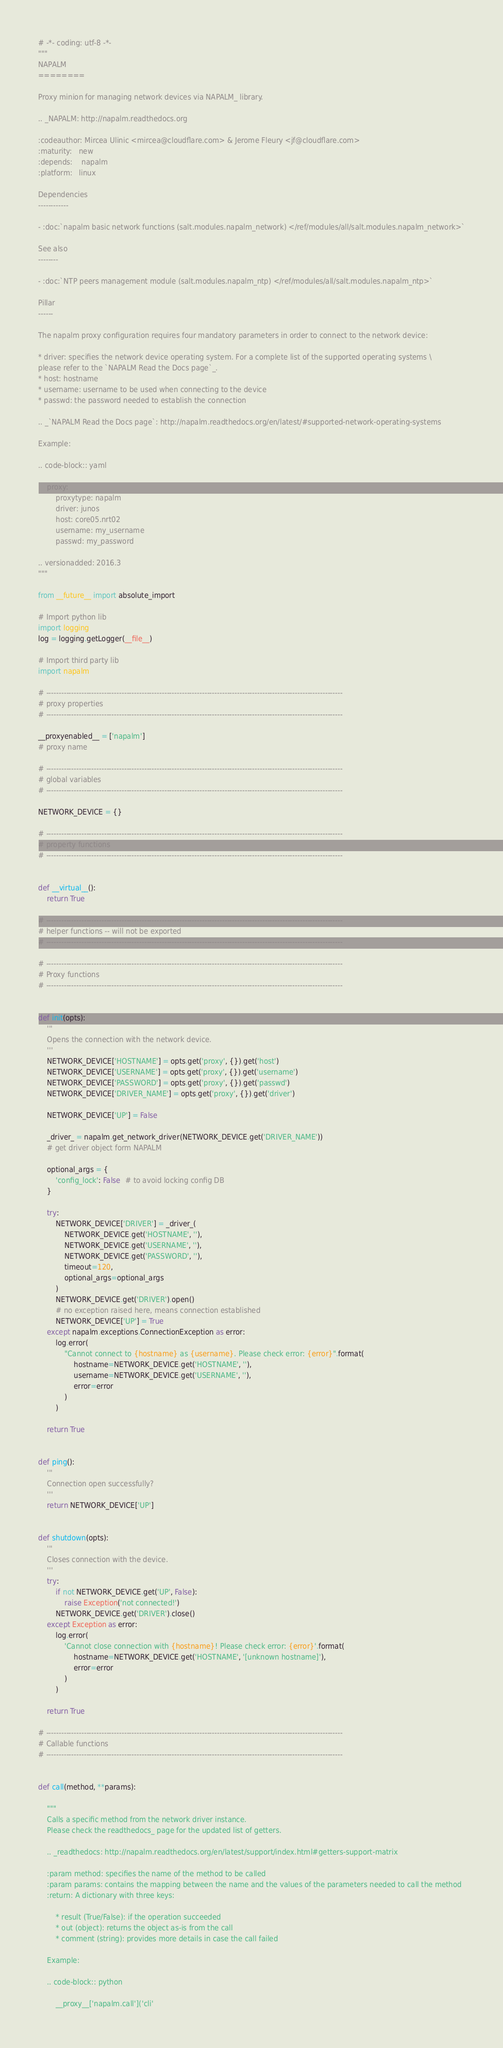<code> <loc_0><loc_0><loc_500><loc_500><_Python_># -*- coding: utf-8 -*-
"""
NAPALM
========

Proxy minion for managing network devices via NAPALM_ library.

.. _NAPALM: http://napalm.readthedocs.org

:codeauthor: Mircea Ulinic <mircea@cloudflare.com> & Jerome Fleury <jf@cloudflare.com>
:maturity:   new
:depends:    napalm
:platform:   linux

Dependencies
------------

- :doc:`napalm basic network functions (salt.modules.napalm_network) </ref/modules/all/salt.modules.napalm_network>`

See also
--------

- :doc:`NTP peers management module (salt.modules.napalm_ntp) </ref/modules/all/salt.modules.napalm_ntp>`

Pillar
------

The napalm proxy configuration requires four mandatory parameters in order to connect to the network device:

* driver: specifies the network device operating system. For a complete list of the supported operating systems \
please refer to the `NAPALM Read the Docs page`_.
* host: hostname
* username: username to be used when connecting to the device
* passwd: the password needed to establish the connection

.. _`NAPALM Read the Docs page`: http://napalm.readthedocs.org/en/latest/#supported-network-operating-systems

Example:

.. code-block:: yaml

    proxy:
        proxytype: napalm
        driver: junos
        host: core05.nrt02
        username: my_username
        passwd: my_password

.. versionadded: 2016.3
"""

from __future__ import absolute_import

# Import python lib
import logging
log = logging.getLogger(__file__)

# Import third party lib
import napalm

# ----------------------------------------------------------------------------------------------------------------------
# proxy properties
# ----------------------------------------------------------------------------------------------------------------------

__proxyenabled__ = ['napalm']
# proxy name

# ----------------------------------------------------------------------------------------------------------------------
# global variables
# ----------------------------------------------------------------------------------------------------------------------

NETWORK_DEVICE = {}

# ----------------------------------------------------------------------------------------------------------------------
# property functions
# ----------------------------------------------------------------------------------------------------------------------


def __virtual__():
    return True

# ----------------------------------------------------------------------------------------------------------------------
# helper functions -- will not be exported
# ----------------------------------------------------------------------------------------------------------------------

# ----------------------------------------------------------------------------------------------------------------------
# Proxy functions
# ----------------------------------------------------------------------------------------------------------------------


def init(opts):
    '''
    Opens the connection with the network device.
    '''
    NETWORK_DEVICE['HOSTNAME'] = opts.get('proxy', {}).get('host')
    NETWORK_DEVICE['USERNAME'] = opts.get('proxy', {}).get('username')
    NETWORK_DEVICE['PASSWORD'] = opts.get('proxy', {}).get('passwd')
    NETWORK_DEVICE['DRIVER_NAME'] = opts.get('proxy', {}).get('driver')

    NETWORK_DEVICE['UP'] = False

    _driver_ = napalm.get_network_driver(NETWORK_DEVICE.get('DRIVER_NAME'))
    # get driver object form NAPALM

    optional_args = {
        'config_lock': False  # to avoid locking config DB
    }

    try:
        NETWORK_DEVICE['DRIVER'] = _driver_(
            NETWORK_DEVICE.get('HOSTNAME', ''),
            NETWORK_DEVICE.get('USERNAME', ''),
            NETWORK_DEVICE.get('PASSWORD', ''),
            timeout=120,
            optional_args=optional_args
        )
        NETWORK_DEVICE.get('DRIVER').open()
        # no exception raised here, means connection established
        NETWORK_DEVICE['UP'] = True
    except napalm.exceptions.ConnectionException as error:
        log.error(
            "Cannot connect to {hostname} as {username}. Please check error: {error}".format(
                hostname=NETWORK_DEVICE.get('HOSTNAME', ''),
                username=NETWORK_DEVICE.get('USERNAME', ''),
                error=error
            )
        )

    return True


def ping():
    '''
    Connection open successfully?
    '''
    return NETWORK_DEVICE['UP']


def shutdown(opts):
    '''
    Closes connection with the device.
    '''
    try:
        if not NETWORK_DEVICE.get('UP', False):
            raise Exception('not connected!')
        NETWORK_DEVICE.get('DRIVER').close()
    except Exception as error:
        log.error(
            'Cannot close connection with {hostname}! Please check error: {error}'.format(
                hostname=NETWORK_DEVICE.get('HOSTNAME', '[unknown hostname]'),
                error=error
            )
        )

    return True

# ----------------------------------------------------------------------------------------------------------------------
# Callable functions
# ----------------------------------------------------------------------------------------------------------------------


def call(method, **params):

    """
    Calls a specific method from the network driver instance.
    Please check the readthedocs_ page for the updated list of getters.

    .. _readthedocs: http://napalm.readthedocs.org/en/latest/support/index.html#getters-support-matrix

    :param method: specifies the name of the method to be called
    :param params: contains the mapping between the name and the values of the parameters needed to call the method
    :return: A dictionary with three keys:

        * result (True/False): if the operation succeeded
        * out (object): returns the object as-is from the call
        * comment (string): provides more details in case the call failed

    Example:

    .. code-block:: python

        __proxy__['napalm.call']('cli'</code> 